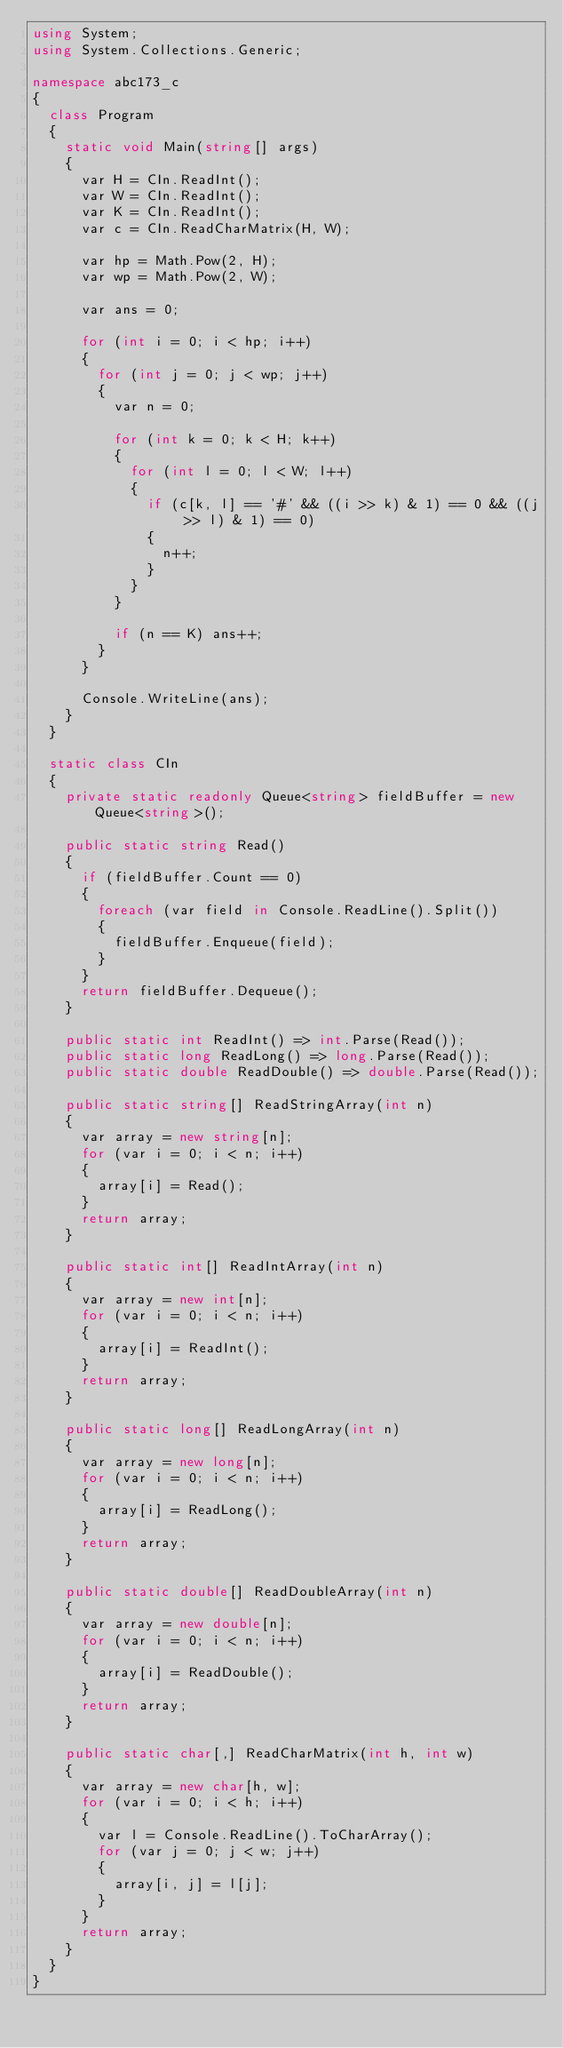Convert code to text. <code><loc_0><loc_0><loc_500><loc_500><_C#_>using System;
using System.Collections.Generic;

namespace abc173_c
{
  class Program
  {
    static void Main(string[] args)
    {
      var H = CIn.ReadInt();
      var W = CIn.ReadInt();
      var K = CIn.ReadInt();
      var c = CIn.ReadCharMatrix(H, W);

      var hp = Math.Pow(2, H);
      var wp = Math.Pow(2, W);

      var ans = 0;

      for (int i = 0; i < hp; i++)
      {
        for (int j = 0; j < wp; j++)
        {
          var n = 0;

          for (int k = 0; k < H; k++)
          {
            for (int l = 0; l < W; l++)
            {
              if (c[k, l] == '#' && ((i >> k) & 1) == 0 && ((j >> l) & 1) == 0)
              {
                n++;
              }
            }
          }

          if (n == K) ans++;
        }
      }

      Console.WriteLine(ans);
    }
  }

  static class CIn
  {
    private static readonly Queue<string> fieldBuffer = new Queue<string>();

    public static string Read()
    {
      if (fieldBuffer.Count == 0)
      {
        foreach (var field in Console.ReadLine().Split())
        {
          fieldBuffer.Enqueue(field);
        }
      }
      return fieldBuffer.Dequeue();
    }

    public static int ReadInt() => int.Parse(Read());
    public static long ReadLong() => long.Parse(Read());
    public static double ReadDouble() => double.Parse(Read());

    public static string[] ReadStringArray(int n)
    {
      var array = new string[n];
      for (var i = 0; i < n; i++)
      {
        array[i] = Read();
      }
      return array;
    }

    public static int[] ReadIntArray(int n)
    {
      var array = new int[n];
      for (var i = 0; i < n; i++)
      {
        array[i] = ReadInt();
      }
      return array;
    }

    public static long[] ReadLongArray(int n)
    {
      var array = new long[n];
      for (var i = 0; i < n; i++)
      {
        array[i] = ReadLong();
      }
      return array;
    }

    public static double[] ReadDoubleArray(int n)
    {
      var array = new double[n];
      for (var i = 0; i < n; i++)
      {
        array[i] = ReadDouble();
      }
      return array;
    }

    public static char[,] ReadCharMatrix(int h, int w)
    {
      var array = new char[h, w];
      for (var i = 0; i < h; i++)
      {
        var l = Console.ReadLine().ToCharArray();
        for (var j = 0; j < w; j++)
        {
          array[i, j] = l[j];
        }
      }
      return array;
    }
  }
}
</code> 